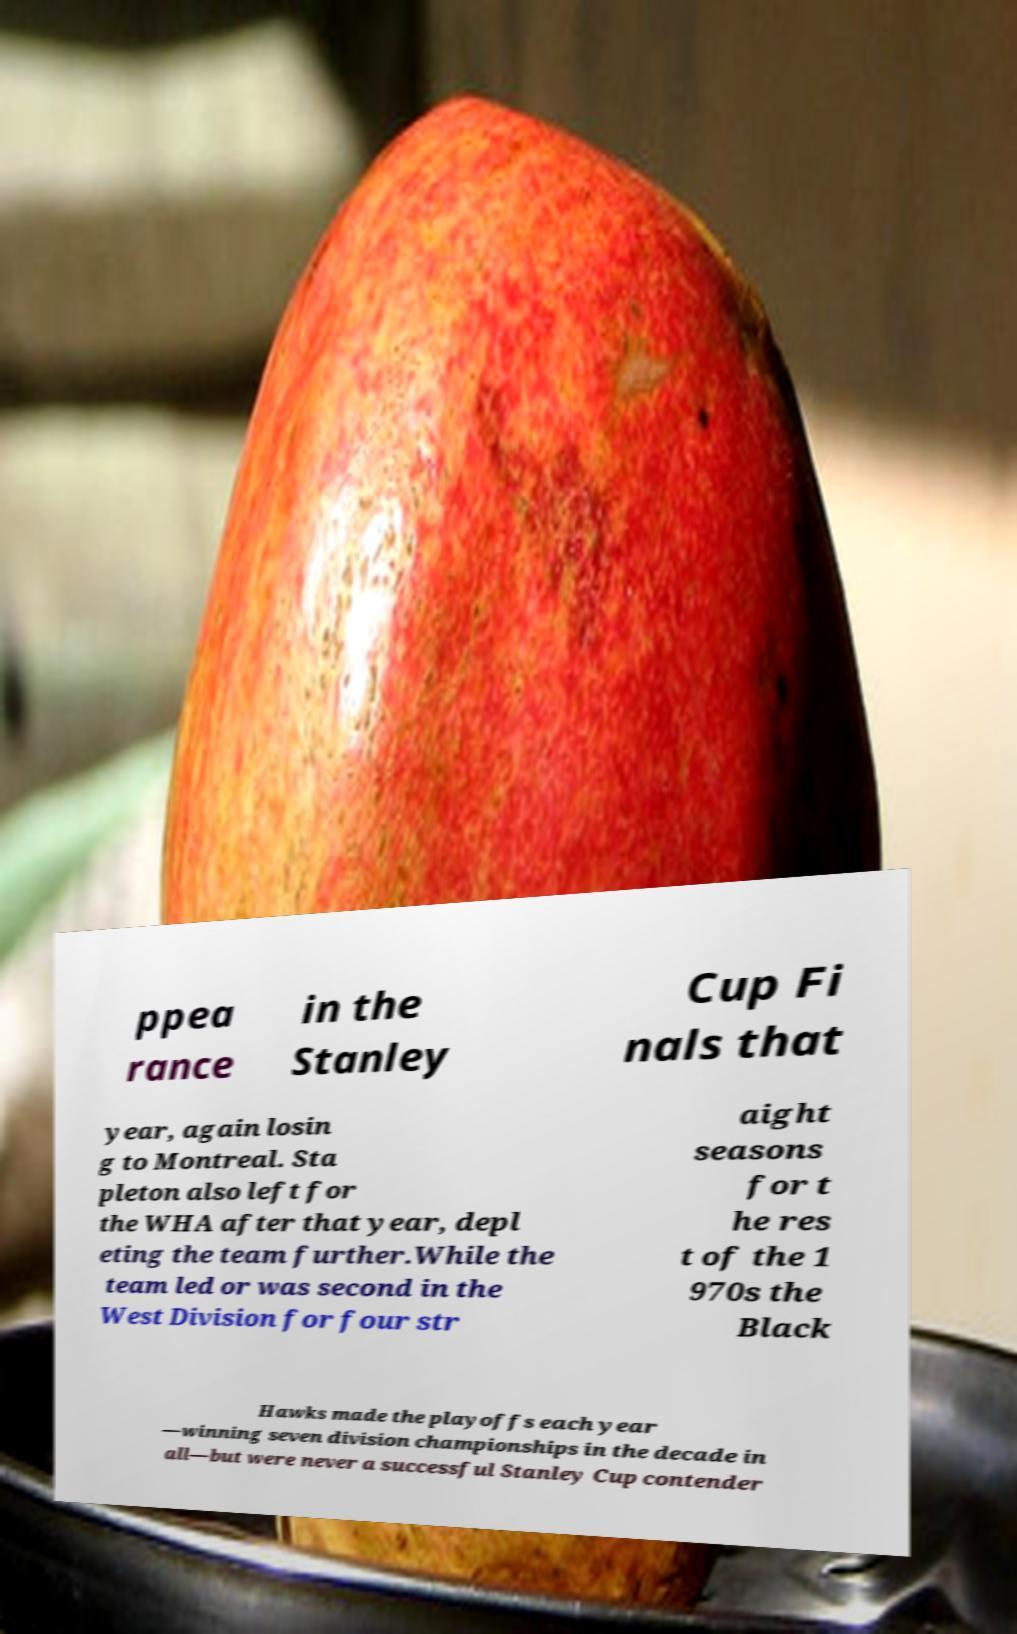I need the written content from this picture converted into text. Can you do that? ppea rance in the Stanley Cup Fi nals that year, again losin g to Montreal. Sta pleton also left for the WHA after that year, depl eting the team further.While the team led or was second in the West Division for four str aight seasons for t he res t of the 1 970s the Black Hawks made the playoffs each year —winning seven division championships in the decade in all—but were never a successful Stanley Cup contender 